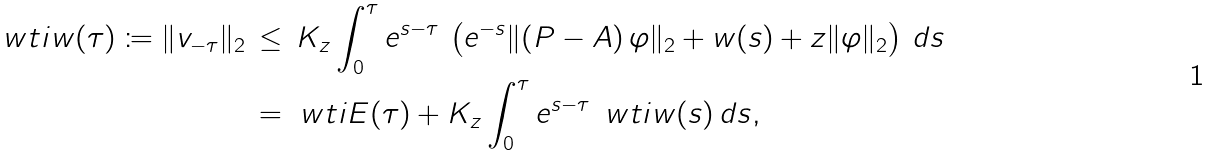Convert formula to latex. <formula><loc_0><loc_0><loc_500><loc_500>\ w t i { w } ( \tau ) \coloneqq \| v _ { - \tau } \| _ { 2 } \, & \leq \, K _ { z } \int _ { 0 } ^ { \tau } e ^ { s - \tau } \, \left ( e ^ { - s } \| ( P - A ) \, \varphi \| _ { 2 } + w ( s ) + z \| \varphi \| _ { 2 } \right ) \, d s \\ & = \ w t i { E } ( \tau ) + K _ { z } \int _ { 0 } ^ { \tau } e ^ { s - \tau } \, \ w t i { w } ( s ) \, d s ,</formula> 